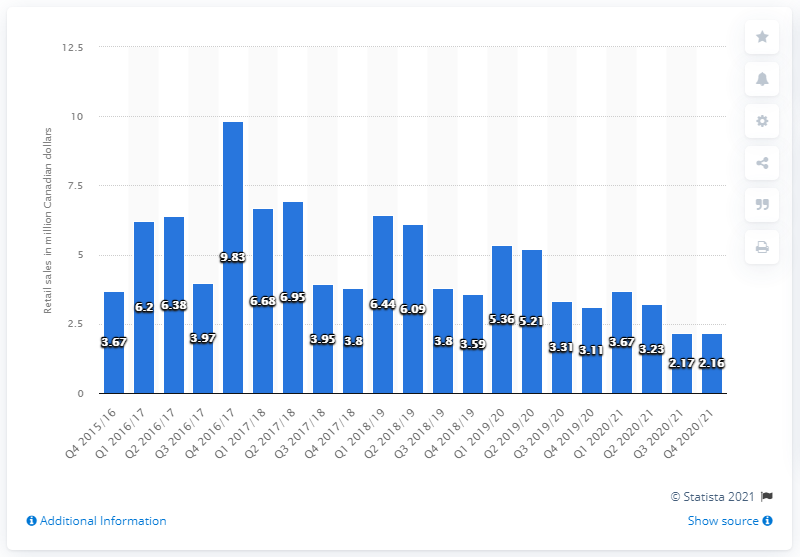List a handful of essential elements in this visual. In the fourth quarter of 2020/21, the retail sales of imported cider in British Columbia were 2.16 million. 